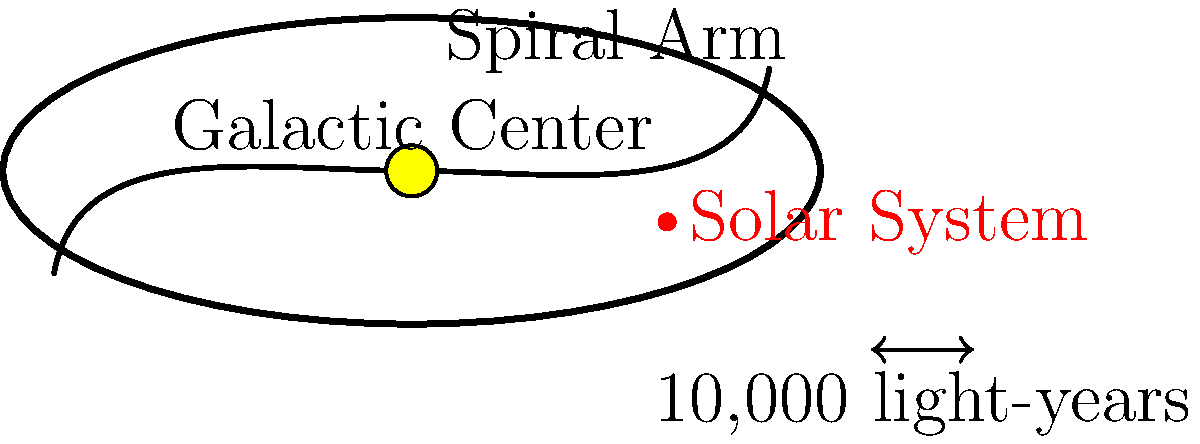As a parent who values both practicality and pursuing one's passions, you want to inspire your theatre-loving child with the vastness of the universe. Explain the structure of our Milky Way galaxy and locate our Solar System within it. How far is our Solar System from the galactic center, and what does this tell us about our position in the galaxy? 1. Galaxy Structure: The Milky Way is a spiral galaxy, consisting of a central bulge and spiral arms extending outward.

2. Central Bulge: At the center is a dense concentration of stars, including a supermassive black hole. This region is called the galactic center or central bulge.

3. Spiral Arms: Extending from the central bulge are spiral arms, where most stars, including our Sun, are located. These arms contain gas, dust, and regions of active star formation.

4. Solar System Position: Our Solar System is located in one of the spiral arms, called the Orion Arm or Local Arm.

5. Distance from Center: The Solar System is approximately 26,000 light-years from the galactic center. This can be calculated using various methods, including observing the motions of stars and measuring the distances to globular clusters.

6. Galactic Perspective: This distance places us about halfway between the center and the edge of the galaxy's visible disk, which is roughly 100,000 light-years in diameter.

7. Implications: Our position in the galaxy affects our view of the universe, the types of stars and phenomena we can observe, and even the potential for life (as we're in a relatively stable region, neither too close to the intense radiation of the galactic center nor too far in the sparse outer regions).
Answer: The Solar System is located in a spiral arm, approximately 26,000 light-years from the galactic center, placing us in the mid-region of the Milky Way's disk. 